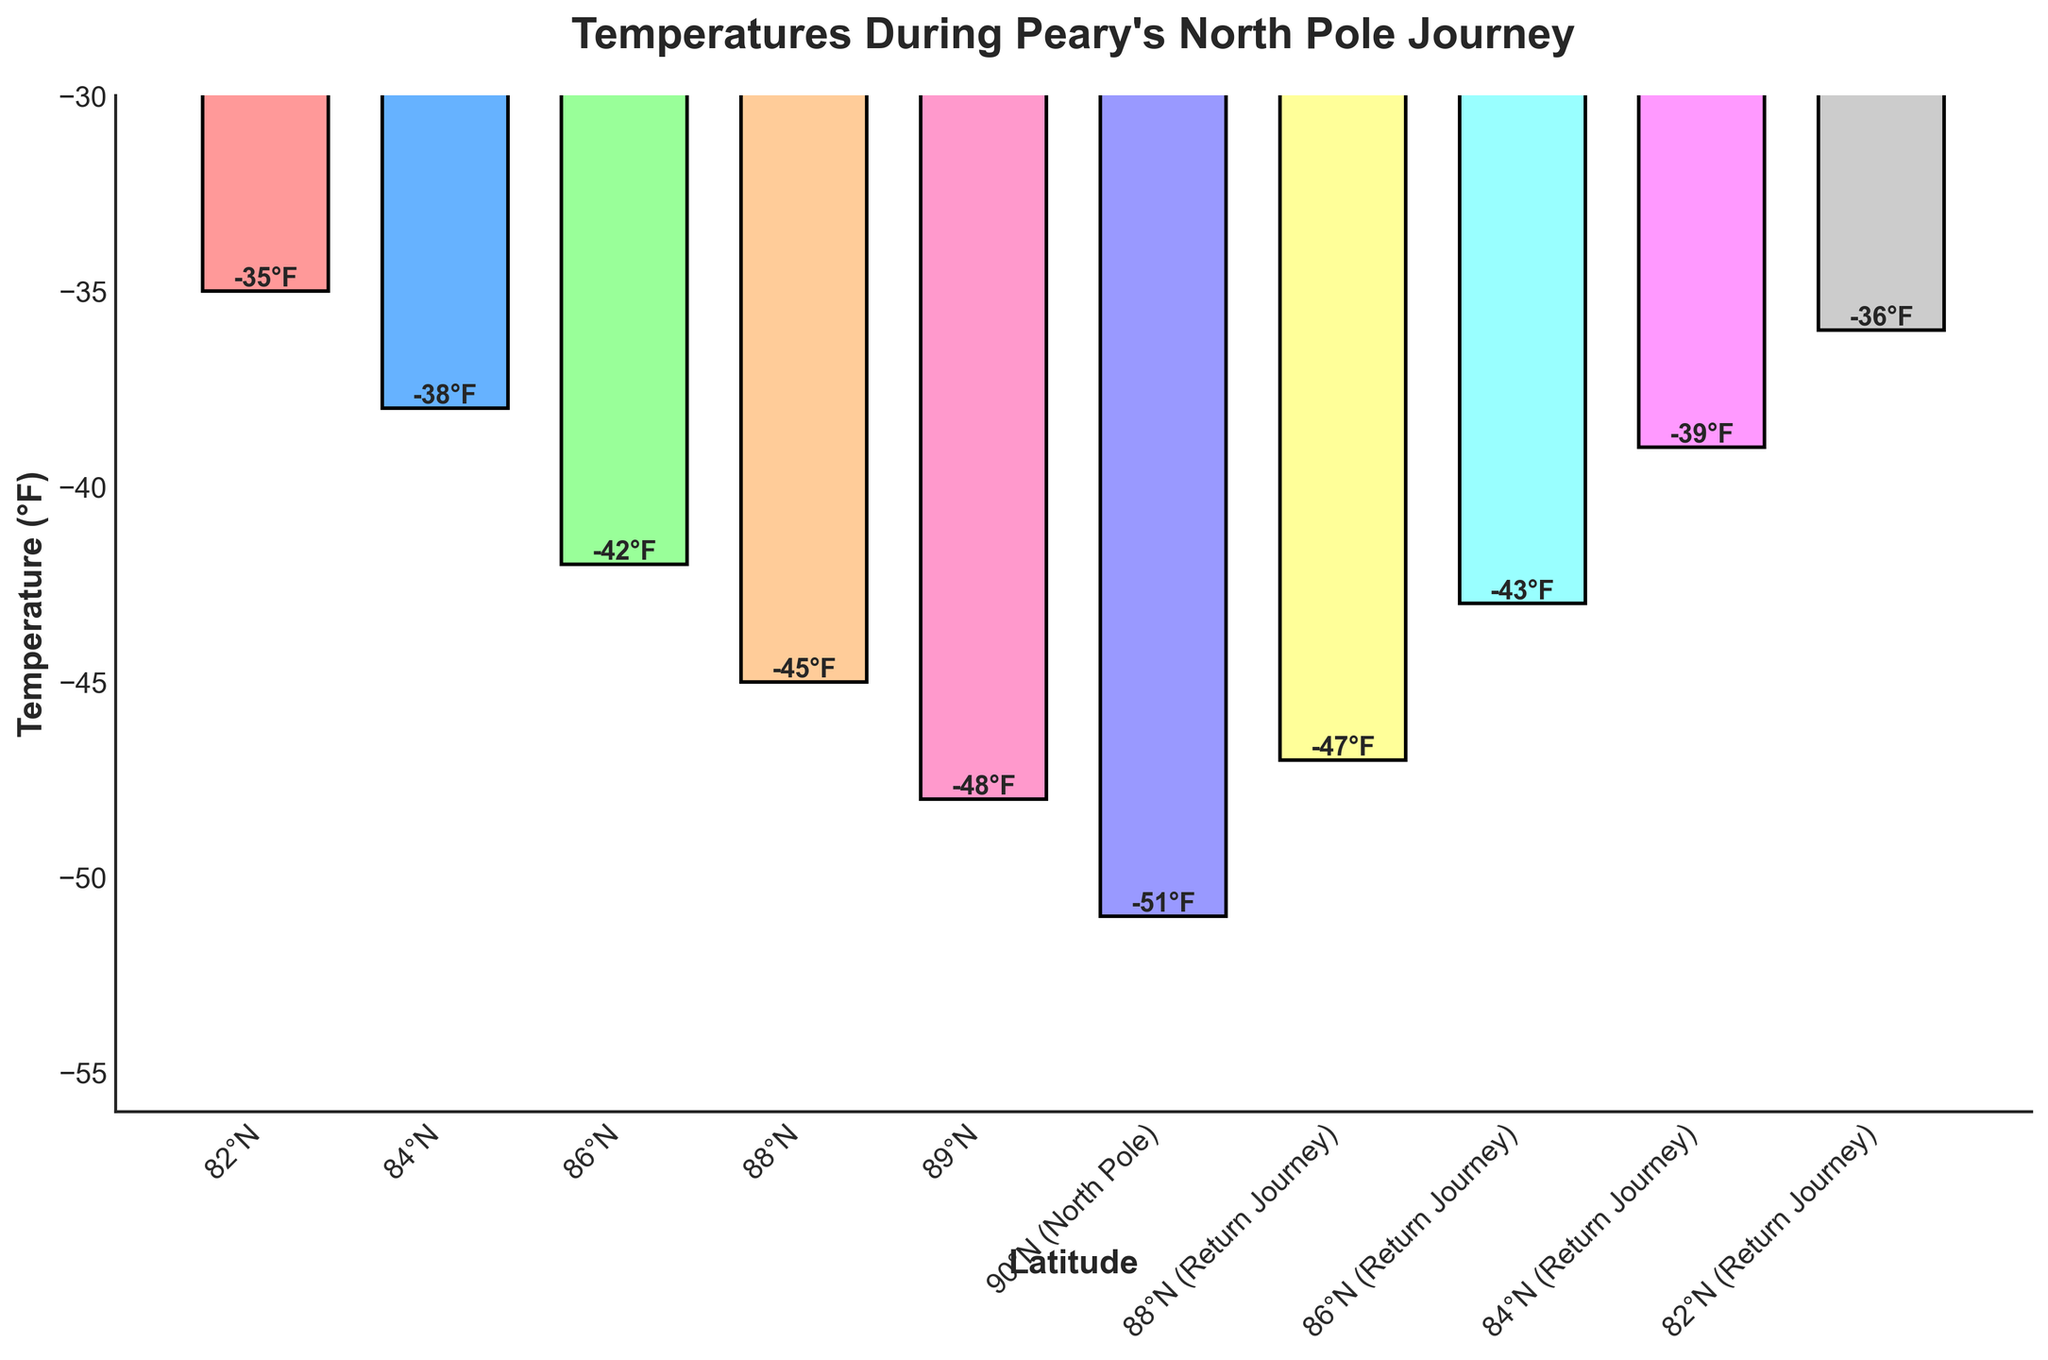What is the coldest temperature recorded during Peary's North Pole journey? The coldest temperature is the lowest value on the y-axis of the bar chart, which is the bar at 90°N (North Pole) with -51°F.
Answer: -51°F Which latitude on Peary's journey recorded a temperature of -43°F? By looking at the y-axis values and matching it to the corresponding bars, -43°F is recorded at 86°N on the return journey.
Answer: 86°N (Return Journey) What is the average temperature recorded at latitudes 82°N, 84°N, and 86°N on the initial journey? Summing up the temperatures at these latitudes: -35 + -38 + -42 = -115. Then, divide by 3 to find the average: -115/3 ≈ -38.33.
Answer: -38.33°F Compare the temperature recorded at 84°N and 88°N on the initial journey. Which one is colder and by how much? The temperature at 84°N is -38°F, and at 88°N it is -45°F. -45°F is colder. The difference is -45 - (-38) = -45 + 38 = -7°F.
Answer: 88°N is colder by 7°F What is the difference in temperature between 82°N on the initial journey and 82°N on the return journey? The temperature at 82°N on the initial journey is -35°F, and on the return journey, it is -36°F. The difference is -36 - (-35) = -36 + 35 = -1°F.
Answer: 1°F At which latitude does the return journey show the smallest temperature change compared to the initial journey? By examining the temperatures at each latitude on both the initial and return journeys, the smallest change occurs at 82°N: -35°F to -36°F, a difference of 1°F.
Answer: 82°N Which bar in the chart is the tallest? The tallest bar represents the coldest temperature, which occurs at 90°N (North Pole) with -51°F.
Answer: 90°N (North Pole) What is the average temperature across all recorded latitudes during Peary's journey? Sum the temperatures of all recorded latitudes and then divide by the number of data points: (-35 -38 -42 -45 -48 -51 -47 -43 -39 -36) / 10 = -424 / 10 = -42.4°F.
Answer: -42.4°F Which latitude records exactly the midpoint temperature between the coldest and warmest temperatures on the initial journey? The coldest temperature is -51°F and the warmest is -35°F. The midpoint is (-51 + (-35))/2 = -43°F. Checking the initial journey, -43°F is recorded at 86°N.
Answer: 86°N What are the colors of the bars representing the temperatures recorded at 86°N on both the initial and return journeys? The bar colors for these latitudes are the third and eighth bars. They are represented by shades of blue and cyan.
Answer: Blue and Cyan 